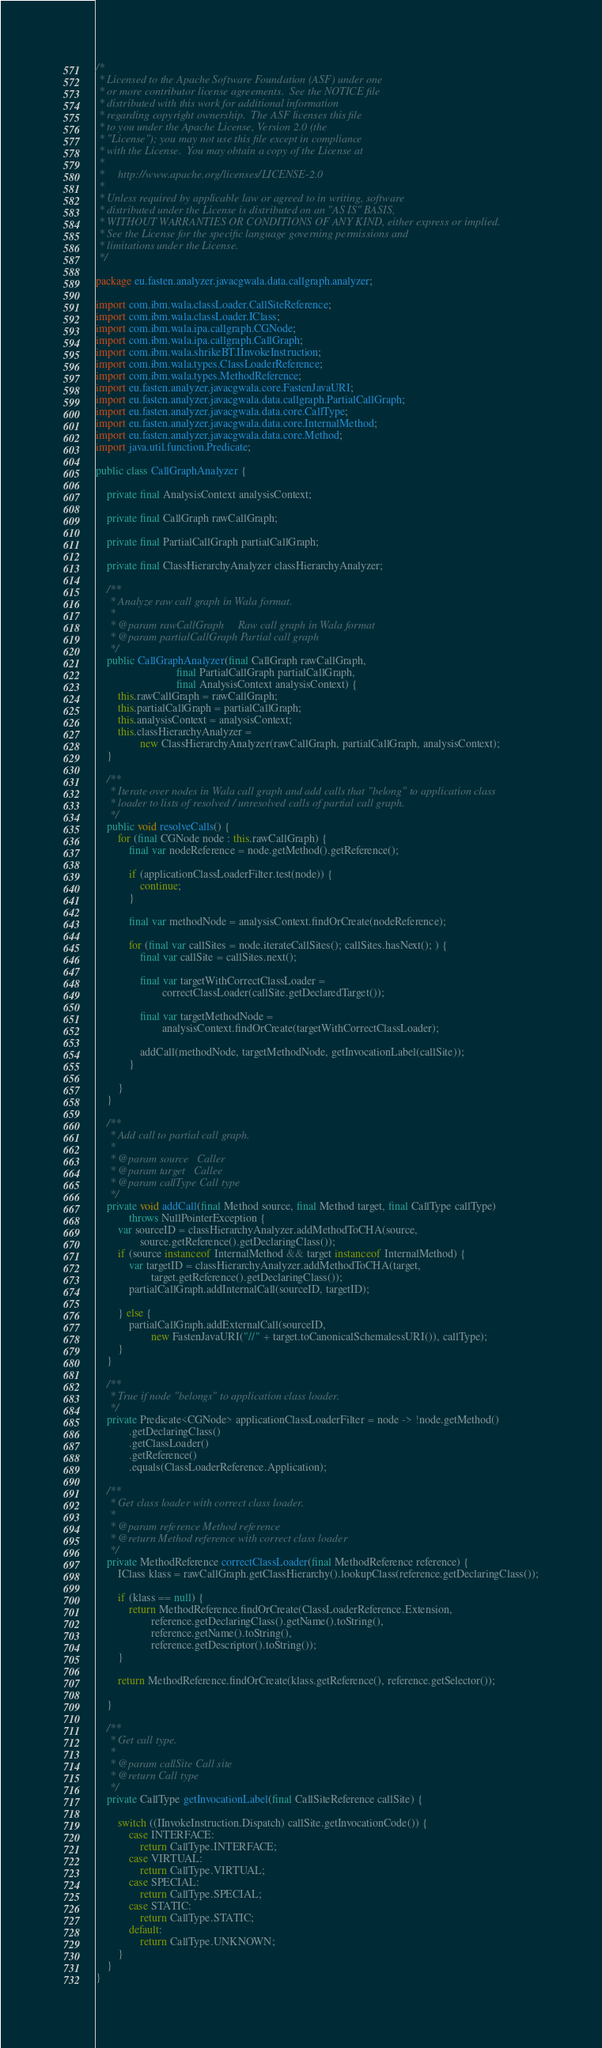<code> <loc_0><loc_0><loc_500><loc_500><_Java_>/*
 * Licensed to the Apache Software Foundation (ASF) under one
 * or more contributor license agreements.  See the NOTICE file
 * distributed with this work for additional information
 * regarding copyright ownership.  The ASF licenses this file
 * to you under the Apache License, Version 2.0 (the
 * "License"); you may not use this file except in compliance
 * with the License.  You may obtain a copy of the License at
 *
 *     http://www.apache.org/licenses/LICENSE-2.0
 *
 * Unless required by applicable law or agreed to in writing, software
 * distributed under the License is distributed on an "AS IS" BASIS,
 * WITHOUT WARRANTIES OR CONDITIONS OF ANY KIND, either express or implied.
 * See the License for the specific language governing permissions and
 * limitations under the License.
 */

package eu.fasten.analyzer.javacgwala.data.callgraph.analyzer;

import com.ibm.wala.classLoader.CallSiteReference;
import com.ibm.wala.classLoader.IClass;
import com.ibm.wala.ipa.callgraph.CGNode;
import com.ibm.wala.ipa.callgraph.CallGraph;
import com.ibm.wala.shrikeBT.IInvokeInstruction;
import com.ibm.wala.types.ClassLoaderReference;
import com.ibm.wala.types.MethodReference;
import eu.fasten.analyzer.javacgwala.core.FastenJavaURI;
import eu.fasten.analyzer.javacgwala.data.callgraph.PartialCallGraph;
import eu.fasten.analyzer.javacgwala.data.core.CallType;
import eu.fasten.analyzer.javacgwala.data.core.InternalMethod;
import eu.fasten.analyzer.javacgwala.data.core.Method;
import java.util.function.Predicate;

public class CallGraphAnalyzer {

    private final AnalysisContext analysisContext;

    private final CallGraph rawCallGraph;

    private final PartialCallGraph partialCallGraph;

    private final ClassHierarchyAnalyzer classHierarchyAnalyzer;

    /**
     * Analyze raw call graph in Wala format.
     *
     * @param rawCallGraph     Raw call graph in Wala format
     * @param partialCallGraph Partial call graph
     */
    public CallGraphAnalyzer(final CallGraph rawCallGraph,
                             final PartialCallGraph partialCallGraph,
                             final AnalysisContext analysisContext) {
        this.rawCallGraph = rawCallGraph;
        this.partialCallGraph = partialCallGraph;
        this.analysisContext = analysisContext;
        this.classHierarchyAnalyzer =
                new ClassHierarchyAnalyzer(rawCallGraph, partialCallGraph, analysisContext);
    }

    /**
     * Iterate over nodes in Wala call graph and add calls that "belong" to application class
     * loader to lists of resolved / unresolved calls of partial call graph.
     */
    public void resolveCalls() {
        for (final CGNode node : this.rawCallGraph) {
            final var nodeReference = node.getMethod().getReference();

            if (applicationClassLoaderFilter.test(node)) {
                continue;
            }

            final var methodNode = analysisContext.findOrCreate(nodeReference);

            for (final var callSites = node.iterateCallSites(); callSites.hasNext(); ) {
                final var callSite = callSites.next();

                final var targetWithCorrectClassLoader =
                        correctClassLoader(callSite.getDeclaredTarget());

                final var targetMethodNode =
                        analysisContext.findOrCreate(targetWithCorrectClassLoader);

                addCall(methodNode, targetMethodNode, getInvocationLabel(callSite));
            }

        }
    }

    /**
     * Add call to partial call graph.
     *
     * @param source   Caller
     * @param target   Callee
     * @param callType Call type
     */
    private void addCall(final Method source, final Method target, final CallType callType)
            throws NullPointerException {
        var sourceID = classHierarchyAnalyzer.addMethodToCHA(source,
                source.getReference().getDeclaringClass());
        if (source instanceof InternalMethod && target instanceof InternalMethod) {
            var targetID = classHierarchyAnalyzer.addMethodToCHA(target,
                    target.getReference().getDeclaringClass());
            partialCallGraph.addInternalCall(sourceID, targetID);

        } else {
            partialCallGraph.addExternalCall(sourceID,
                    new FastenJavaURI("//" + target.toCanonicalSchemalessURI()), callType);
        }
    }

    /**
     * True if node "belongs" to application class loader.
     */
    private Predicate<CGNode> applicationClassLoaderFilter = node -> !node.getMethod()
            .getDeclaringClass()
            .getClassLoader()
            .getReference()
            .equals(ClassLoaderReference.Application);

    /**
     * Get class loader with correct class loader.
     *
     * @param reference Method reference
     * @return Method reference with correct class loader
     */
    private MethodReference correctClassLoader(final MethodReference reference) {
        IClass klass = rawCallGraph.getClassHierarchy().lookupClass(reference.getDeclaringClass());

        if (klass == null) {
            return MethodReference.findOrCreate(ClassLoaderReference.Extension,
                    reference.getDeclaringClass().getName().toString(),
                    reference.getName().toString(),
                    reference.getDescriptor().toString());
        }

        return MethodReference.findOrCreate(klass.getReference(), reference.getSelector());

    }

    /**
     * Get call type.
     *
     * @param callSite Call site
     * @return Call type
     */
    private CallType getInvocationLabel(final CallSiteReference callSite) {

        switch ((IInvokeInstruction.Dispatch) callSite.getInvocationCode()) {
            case INTERFACE:
                return CallType.INTERFACE;
            case VIRTUAL:
                return CallType.VIRTUAL;
            case SPECIAL:
                return CallType.SPECIAL;
            case STATIC:
                return CallType.STATIC;
            default:
                return CallType.UNKNOWN;
        }
    }
}
</code> 